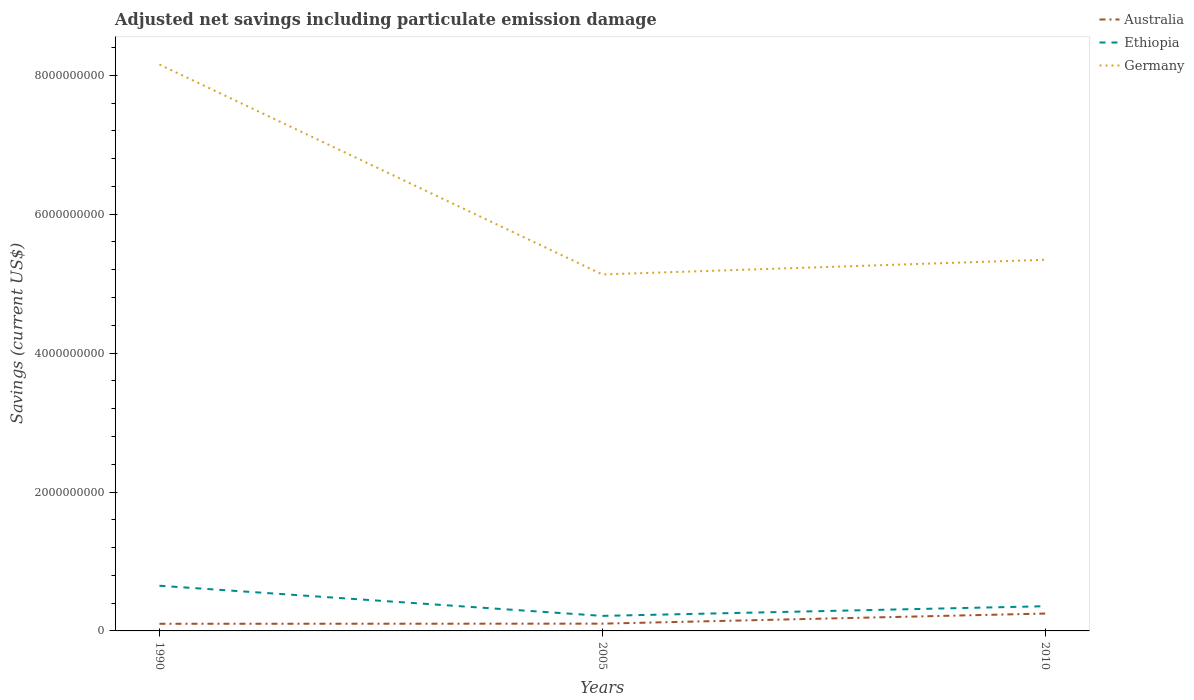How many different coloured lines are there?
Provide a short and direct response. 3. Does the line corresponding to Germany intersect with the line corresponding to Australia?
Keep it short and to the point. No. Is the number of lines equal to the number of legend labels?
Offer a terse response. Yes. Across all years, what is the maximum net savings in Germany?
Give a very brief answer. 5.13e+09. In which year was the net savings in Germany maximum?
Your response must be concise. 2005. What is the total net savings in Germany in the graph?
Offer a very short reply. 2.81e+09. What is the difference between the highest and the second highest net savings in Germany?
Give a very brief answer. 3.02e+09. What is the difference between the highest and the lowest net savings in Australia?
Provide a succinct answer. 1. Is the net savings in Germany strictly greater than the net savings in Ethiopia over the years?
Keep it short and to the point. No. How many years are there in the graph?
Offer a very short reply. 3. What is the difference between two consecutive major ticks on the Y-axis?
Make the answer very short. 2.00e+09. Are the values on the major ticks of Y-axis written in scientific E-notation?
Your response must be concise. No. Does the graph contain any zero values?
Ensure brevity in your answer.  No. How many legend labels are there?
Give a very brief answer. 3. What is the title of the graph?
Give a very brief answer. Adjusted net savings including particulate emission damage. What is the label or title of the Y-axis?
Offer a terse response. Savings (current US$). What is the Savings (current US$) in Australia in 1990?
Give a very brief answer. 1.03e+08. What is the Savings (current US$) in Ethiopia in 1990?
Make the answer very short. 6.50e+08. What is the Savings (current US$) of Germany in 1990?
Ensure brevity in your answer.  8.15e+09. What is the Savings (current US$) of Australia in 2005?
Make the answer very short. 1.05e+08. What is the Savings (current US$) of Ethiopia in 2005?
Make the answer very short. 2.16e+08. What is the Savings (current US$) of Germany in 2005?
Offer a very short reply. 5.13e+09. What is the Savings (current US$) in Australia in 2010?
Your response must be concise. 2.50e+08. What is the Savings (current US$) of Ethiopia in 2010?
Give a very brief answer. 3.56e+08. What is the Savings (current US$) of Germany in 2010?
Give a very brief answer. 5.34e+09. Across all years, what is the maximum Savings (current US$) in Australia?
Provide a short and direct response. 2.50e+08. Across all years, what is the maximum Savings (current US$) in Ethiopia?
Offer a terse response. 6.50e+08. Across all years, what is the maximum Savings (current US$) in Germany?
Give a very brief answer. 8.15e+09. Across all years, what is the minimum Savings (current US$) of Australia?
Offer a very short reply. 1.03e+08. Across all years, what is the minimum Savings (current US$) of Ethiopia?
Your answer should be very brief. 2.16e+08. Across all years, what is the minimum Savings (current US$) of Germany?
Provide a succinct answer. 5.13e+09. What is the total Savings (current US$) in Australia in the graph?
Make the answer very short. 4.58e+08. What is the total Savings (current US$) in Ethiopia in the graph?
Your answer should be compact. 1.22e+09. What is the total Savings (current US$) in Germany in the graph?
Your response must be concise. 1.86e+1. What is the difference between the Savings (current US$) of Australia in 1990 and that in 2005?
Give a very brief answer. -1.78e+06. What is the difference between the Savings (current US$) of Ethiopia in 1990 and that in 2005?
Make the answer very short. 4.34e+08. What is the difference between the Savings (current US$) in Germany in 1990 and that in 2005?
Offer a very short reply. 3.02e+09. What is the difference between the Savings (current US$) in Australia in 1990 and that in 2010?
Your answer should be very brief. -1.47e+08. What is the difference between the Savings (current US$) in Ethiopia in 1990 and that in 2010?
Your response must be concise. 2.95e+08. What is the difference between the Savings (current US$) in Germany in 1990 and that in 2010?
Your answer should be compact. 2.81e+09. What is the difference between the Savings (current US$) in Australia in 2005 and that in 2010?
Ensure brevity in your answer.  -1.46e+08. What is the difference between the Savings (current US$) in Ethiopia in 2005 and that in 2010?
Provide a short and direct response. -1.39e+08. What is the difference between the Savings (current US$) of Germany in 2005 and that in 2010?
Provide a succinct answer. -2.11e+08. What is the difference between the Savings (current US$) in Australia in 1990 and the Savings (current US$) in Ethiopia in 2005?
Your response must be concise. -1.14e+08. What is the difference between the Savings (current US$) in Australia in 1990 and the Savings (current US$) in Germany in 2005?
Offer a very short reply. -5.03e+09. What is the difference between the Savings (current US$) of Ethiopia in 1990 and the Savings (current US$) of Germany in 2005?
Provide a succinct answer. -4.48e+09. What is the difference between the Savings (current US$) in Australia in 1990 and the Savings (current US$) in Ethiopia in 2010?
Keep it short and to the point. -2.53e+08. What is the difference between the Savings (current US$) in Australia in 1990 and the Savings (current US$) in Germany in 2010?
Offer a terse response. -5.24e+09. What is the difference between the Savings (current US$) of Ethiopia in 1990 and the Savings (current US$) of Germany in 2010?
Offer a very short reply. -4.69e+09. What is the difference between the Savings (current US$) in Australia in 2005 and the Savings (current US$) in Ethiopia in 2010?
Keep it short and to the point. -2.51e+08. What is the difference between the Savings (current US$) in Australia in 2005 and the Savings (current US$) in Germany in 2010?
Your answer should be very brief. -5.24e+09. What is the difference between the Savings (current US$) of Ethiopia in 2005 and the Savings (current US$) of Germany in 2010?
Offer a terse response. -5.13e+09. What is the average Savings (current US$) in Australia per year?
Provide a short and direct response. 1.53e+08. What is the average Savings (current US$) of Ethiopia per year?
Make the answer very short. 4.07e+08. What is the average Savings (current US$) in Germany per year?
Provide a succinct answer. 6.21e+09. In the year 1990, what is the difference between the Savings (current US$) in Australia and Savings (current US$) in Ethiopia?
Make the answer very short. -5.48e+08. In the year 1990, what is the difference between the Savings (current US$) of Australia and Savings (current US$) of Germany?
Offer a terse response. -8.05e+09. In the year 1990, what is the difference between the Savings (current US$) of Ethiopia and Savings (current US$) of Germany?
Your response must be concise. -7.50e+09. In the year 2005, what is the difference between the Savings (current US$) in Australia and Savings (current US$) in Ethiopia?
Provide a short and direct response. -1.12e+08. In the year 2005, what is the difference between the Savings (current US$) in Australia and Savings (current US$) in Germany?
Ensure brevity in your answer.  -5.03e+09. In the year 2005, what is the difference between the Savings (current US$) in Ethiopia and Savings (current US$) in Germany?
Offer a terse response. -4.92e+09. In the year 2010, what is the difference between the Savings (current US$) of Australia and Savings (current US$) of Ethiopia?
Keep it short and to the point. -1.05e+08. In the year 2010, what is the difference between the Savings (current US$) of Australia and Savings (current US$) of Germany?
Give a very brief answer. -5.09e+09. In the year 2010, what is the difference between the Savings (current US$) in Ethiopia and Savings (current US$) in Germany?
Provide a succinct answer. -4.99e+09. What is the ratio of the Savings (current US$) of Australia in 1990 to that in 2005?
Provide a short and direct response. 0.98. What is the ratio of the Savings (current US$) in Ethiopia in 1990 to that in 2005?
Offer a terse response. 3.01. What is the ratio of the Savings (current US$) of Germany in 1990 to that in 2005?
Offer a terse response. 1.59. What is the ratio of the Savings (current US$) of Australia in 1990 to that in 2010?
Your response must be concise. 0.41. What is the ratio of the Savings (current US$) in Ethiopia in 1990 to that in 2010?
Give a very brief answer. 1.83. What is the ratio of the Savings (current US$) in Germany in 1990 to that in 2010?
Your answer should be compact. 1.53. What is the ratio of the Savings (current US$) of Australia in 2005 to that in 2010?
Offer a very short reply. 0.42. What is the ratio of the Savings (current US$) of Ethiopia in 2005 to that in 2010?
Ensure brevity in your answer.  0.61. What is the ratio of the Savings (current US$) in Germany in 2005 to that in 2010?
Your answer should be compact. 0.96. What is the difference between the highest and the second highest Savings (current US$) of Australia?
Ensure brevity in your answer.  1.46e+08. What is the difference between the highest and the second highest Savings (current US$) in Ethiopia?
Keep it short and to the point. 2.95e+08. What is the difference between the highest and the second highest Savings (current US$) in Germany?
Give a very brief answer. 2.81e+09. What is the difference between the highest and the lowest Savings (current US$) of Australia?
Provide a succinct answer. 1.47e+08. What is the difference between the highest and the lowest Savings (current US$) in Ethiopia?
Your answer should be compact. 4.34e+08. What is the difference between the highest and the lowest Savings (current US$) of Germany?
Offer a very short reply. 3.02e+09. 